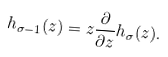<formula> <loc_0><loc_0><loc_500><loc_500>h _ { \sigma - 1 } ( z ) = z \frac { \partial } { \partial z } h _ { \sigma } ( z ) .</formula> 